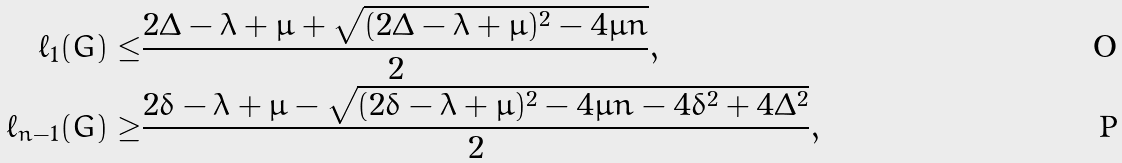Convert formula to latex. <formula><loc_0><loc_0><loc_500><loc_500>\ell _ { 1 } ( G ) \leq & \frac { 2 \Delta - \lambda + \mu + \sqrt { ( 2 \Delta - \lambda + \mu ) ^ { 2 } - 4 \mu n } } { 2 } , \\ \ell _ { n - 1 } ( G ) \geq & \frac { 2 \delta - \lambda + \mu - \sqrt { ( 2 \delta - \lambda + \mu ) ^ { 2 } - 4 \mu n - 4 \delta ^ { 2 } + 4 \Delta ^ { 2 } } } { 2 } ,</formula> 